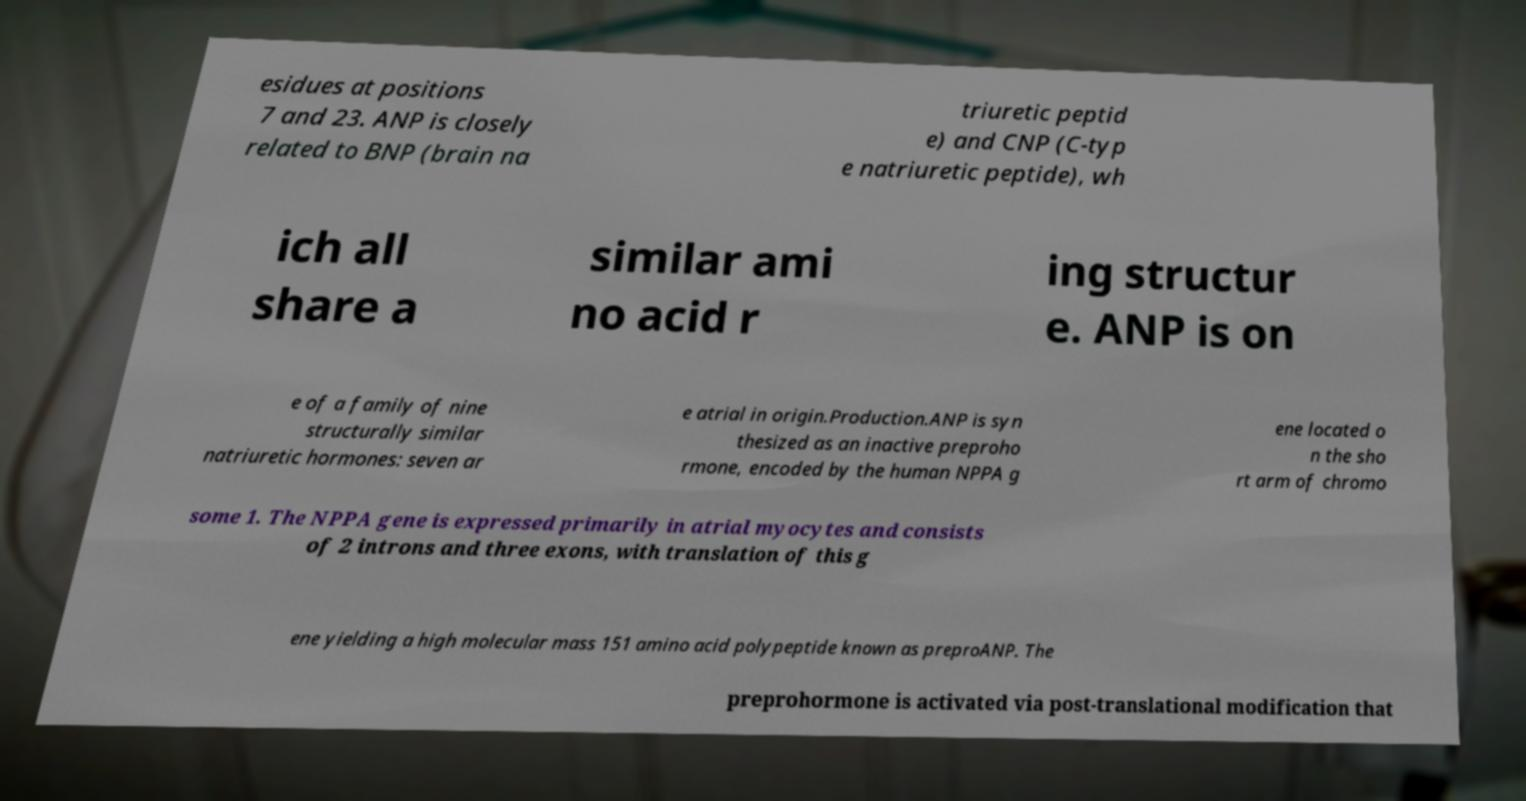There's text embedded in this image that I need extracted. Can you transcribe it verbatim? esidues at positions 7 and 23. ANP is closely related to BNP (brain na triuretic peptid e) and CNP (C-typ e natriuretic peptide), wh ich all share a similar ami no acid r ing structur e. ANP is on e of a family of nine structurally similar natriuretic hormones: seven ar e atrial in origin.Production.ANP is syn thesized as an inactive preproho rmone, encoded by the human NPPA g ene located o n the sho rt arm of chromo some 1. The NPPA gene is expressed primarily in atrial myocytes and consists of 2 introns and three exons, with translation of this g ene yielding a high molecular mass 151 amino acid polypeptide known as preproANP. The preprohormone is activated via post-translational modification that 